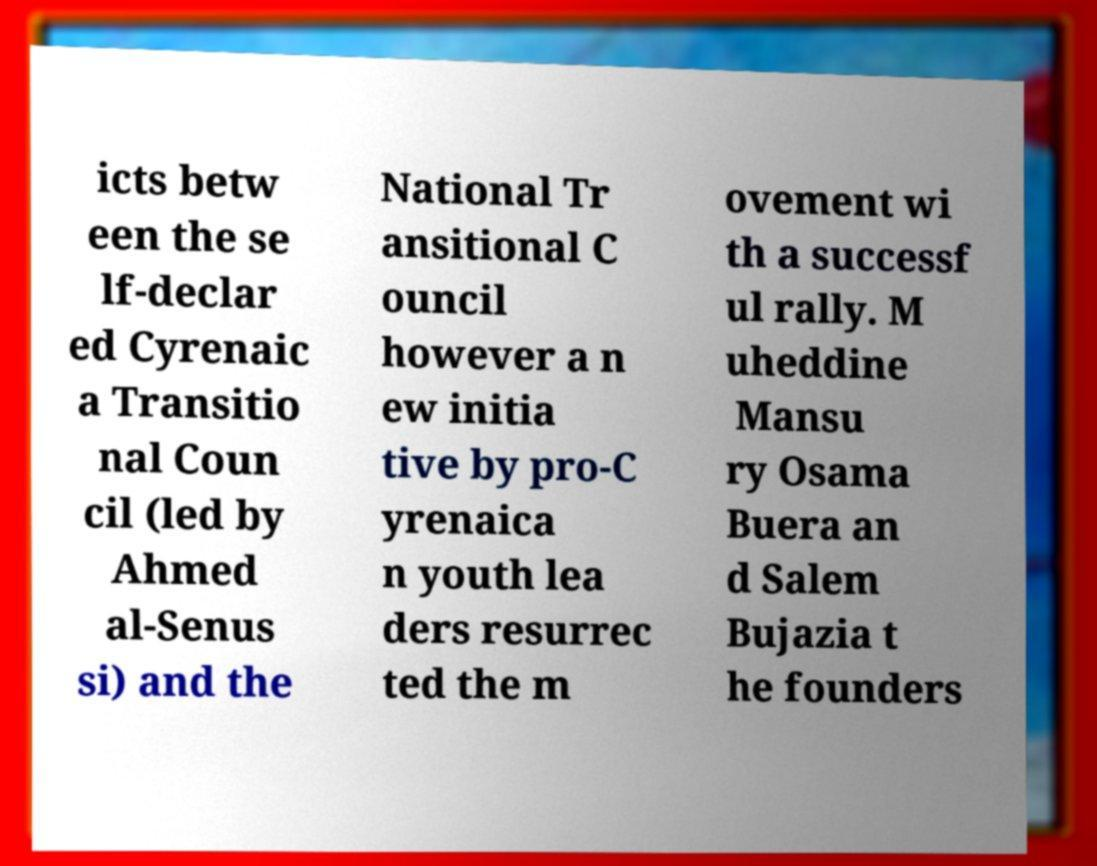I need the written content from this picture converted into text. Can you do that? icts betw een the se lf-declar ed Cyrenaic a Transitio nal Coun cil (led by Ahmed al-Senus si) and the National Tr ansitional C ouncil however a n ew initia tive by pro-C yrenaica n youth lea ders resurrec ted the m ovement wi th a successf ul rally. M uheddine Mansu ry Osama Buera an d Salem Bujazia t he founders 